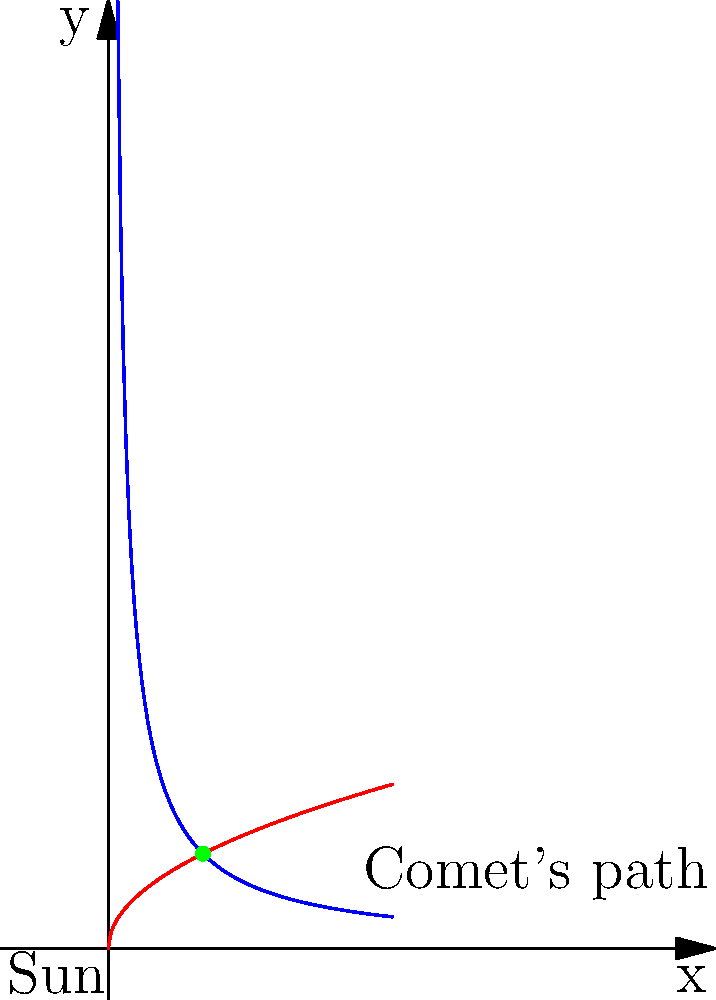As a seasoned broadcaster familiar with the unpredictable nature of political campaigns, you're now faced with a celestial curveball. The image shows two possible paths for a comet approaching the Sun: a hyperbolic path (blue) and a parabolic path (red). Which path would result in the comet escaping the Sun's gravitational pull, and why might this be analogous to the impact of unexpected events in political campaigns? Let's break this down step-by-step:

1. The blue curve represents a hyperbolic path (function: $f(x) = \frac{1}{x}$).
2. The red curve represents a parabolic path (function: $g(x) = \sqrt{x}$).

3. In celestial mechanics:
   a) A hyperbolic orbit has an eccentricity $e > 1$.
   b) A parabolic orbit has an eccentricity $e = 1$.
   c) An elliptical orbit has an eccentricity $0 < e < 1$.

4. The hyperbolic path (blue) extends to infinity, while the parabolic path (red) approaches but never reaches a vertical asymptote.

5. A comet on a hyperbolic path will approach the Sun, swing around it, and then escape its gravitational pull, continuing on a path that takes it out of the solar system.

6. A comet on a parabolic path will approach the Sun, swing around it, and then move away, but its velocity at infinity would be zero, theoretically never completely escaping the Sun's influence.

7. In reality, true parabolic orbits are extremely rare. Most comets follow either slightly hyperbolic or slightly elliptical paths.

Analogy to political campaigns:
Just as a comet's path can be altered by gravitational interactions, leading to unexpected outcomes, political campaigns can be influenced by unforeseen events or data analytics, potentially changing their trajectory in surprising ways.
Answer: Hyperbolic path (blue) 